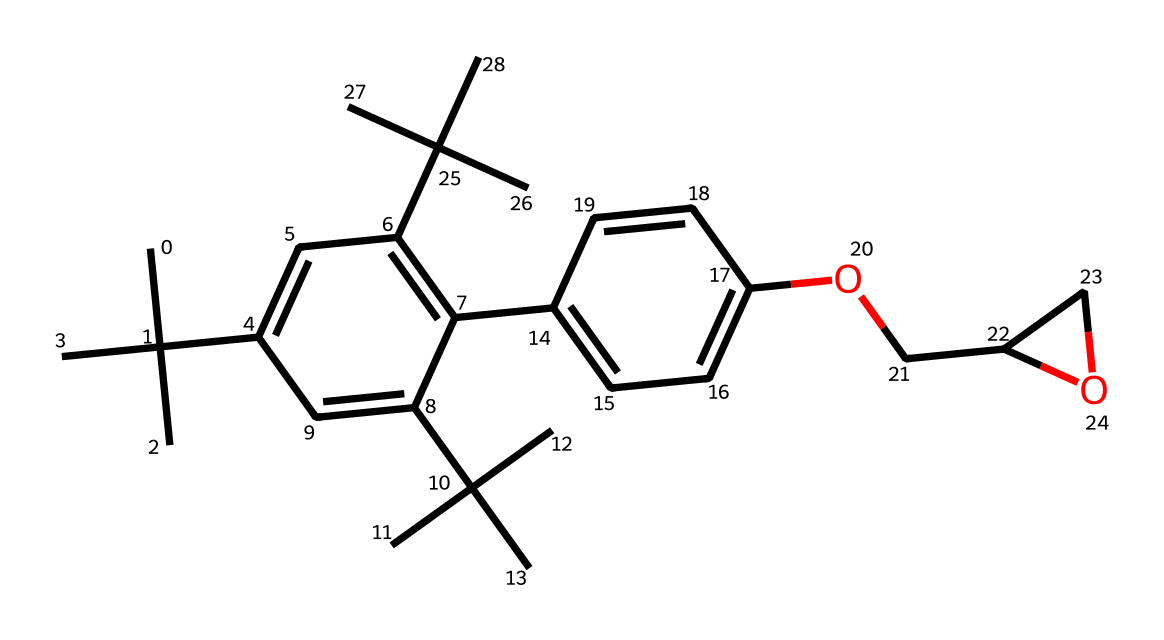What is the molecular formula of this compound? To determine the molecular formula, count the number of each type of atom present in the SMILES representation. For the given SMILES, there are 27 carbon atoms, 38 hydrogen atoms, 3 oxygen atoms, leading to the formula C27H38O3.
Answer: C27H38O3 How many hydroxyl groups are present in the structure? The presence of hydroxyl groups (–OH) can be identified by looking for an oxygen atom directly bonded to a hydrogen atom in the structure. In the provided SMILES, there is one hydroxyl group, indicating it has one –OH functional group.
Answer: 1 What type of polymer does this chemical represent? Given that the compound is described as a light-sensitive polymer used in photoresists, it can be classified as a photochromic polymer due to its ability to undergo a reversible reaction under UV light.
Answer: photochromic How many rings are present in the chemical structure? To find the number of rings, look for the ring-closure indicators in the SMILES, which are numeric (the numbers signify where the ring starts and ends). In the provided structure, there are 2 rings indicated by the numbers in the SMILES representation.
Answer: 2 What kind of linkage is present in the polymer backbone? The structure features carbon-carbon single bonds accounting for the majority of the polymer backbone. In addition, the presence of ether linkages (–O–) can be identified through the oxygen connections between carbon chains in the structure.
Answer: carbon-carbon and ether Which part of this molecule is responsible for light sensitivity? The light sensitivity in photoresists typically arises from specific functional groups that undergo change upon exposure to light, especially conjugated systems. In this case, phenolic groups present in the structure are often responsible for light sensitivity.
Answer: phenolic groups 